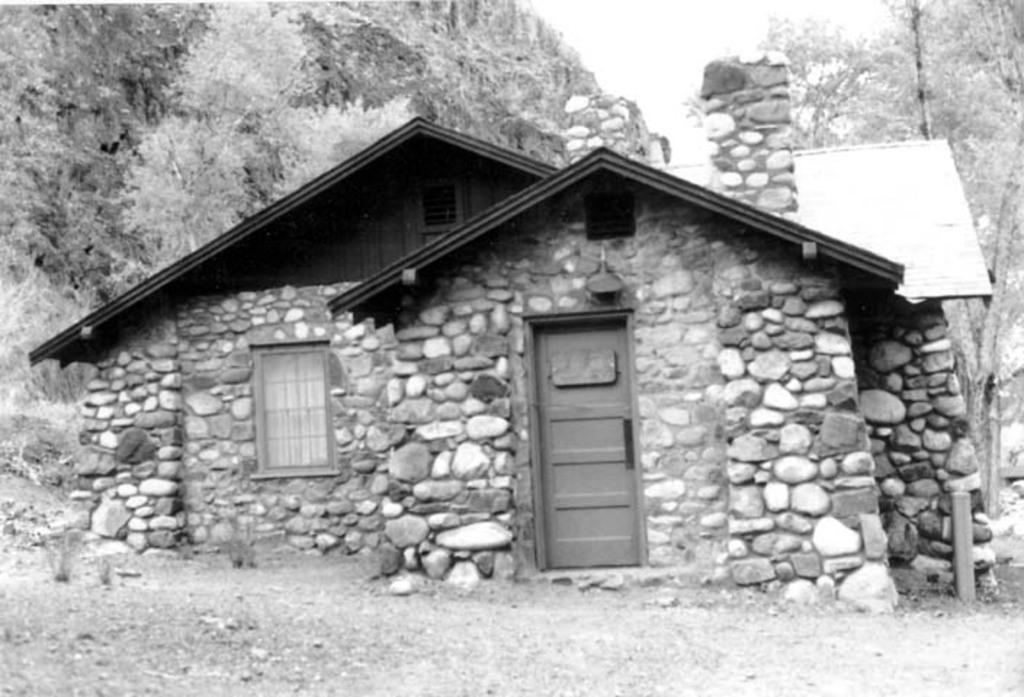Please provide a concise description of this image. This is a black and white image. In the middle of the image there is a house. In the background there are many trees. 